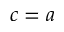<formula> <loc_0><loc_0><loc_500><loc_500>c = a</formula> 